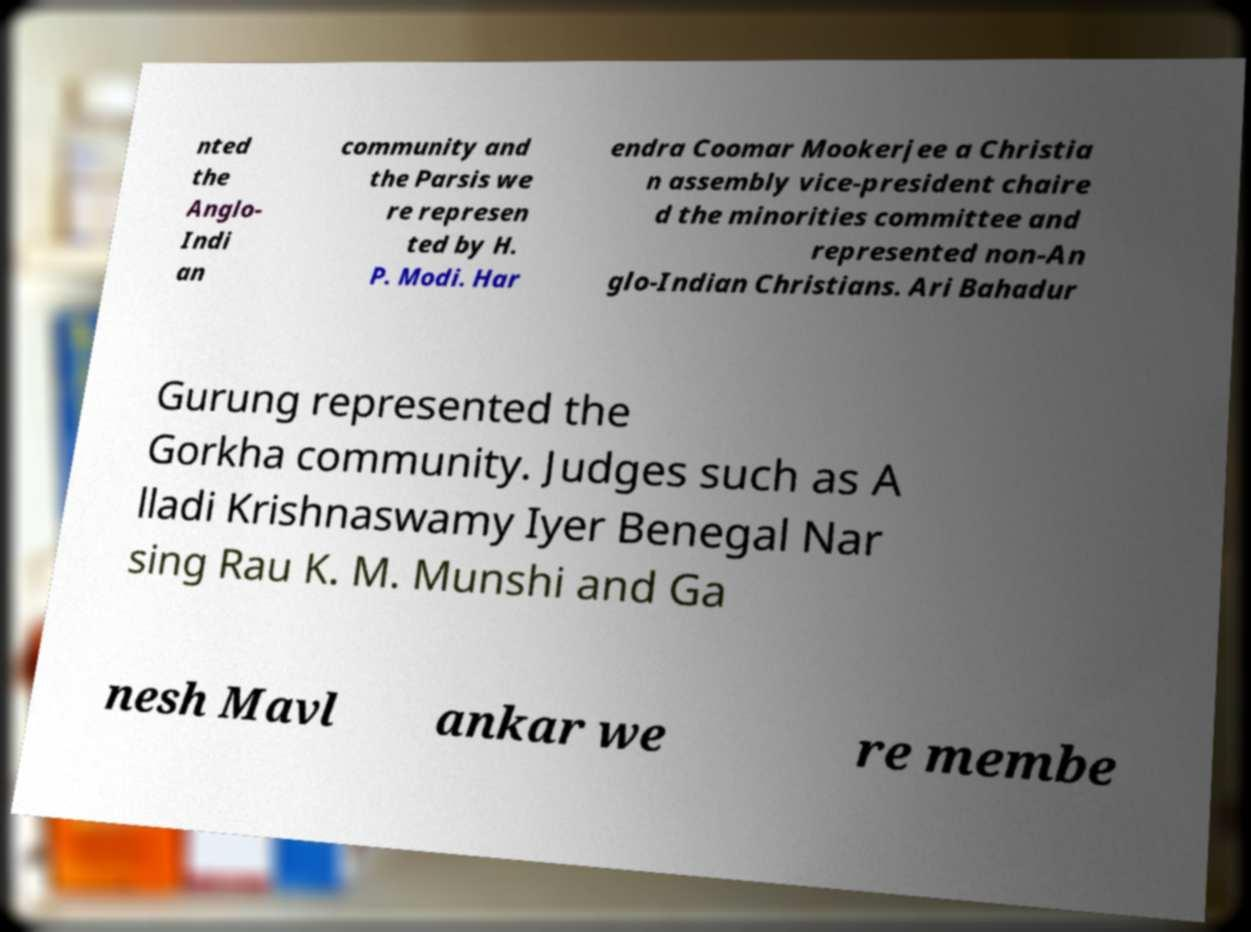I need the written content from this picture converted into text. Can you do that? nted the Anglo- Indi an community and the Parsis we re represen ted by H. P. Modi. Har endra Coomar Mookerjee a Christia n assembly vice-president chaire d the minorities committee and represented non-An glo-Indian Christians. Ari Bahadur Gurung represented the Gorkha community. Judges such as A lladi Krishnaswamy Iyer Benegal Nar sing Rau K. M. Munshi and Ga nesh Mavl ankar we re membe 